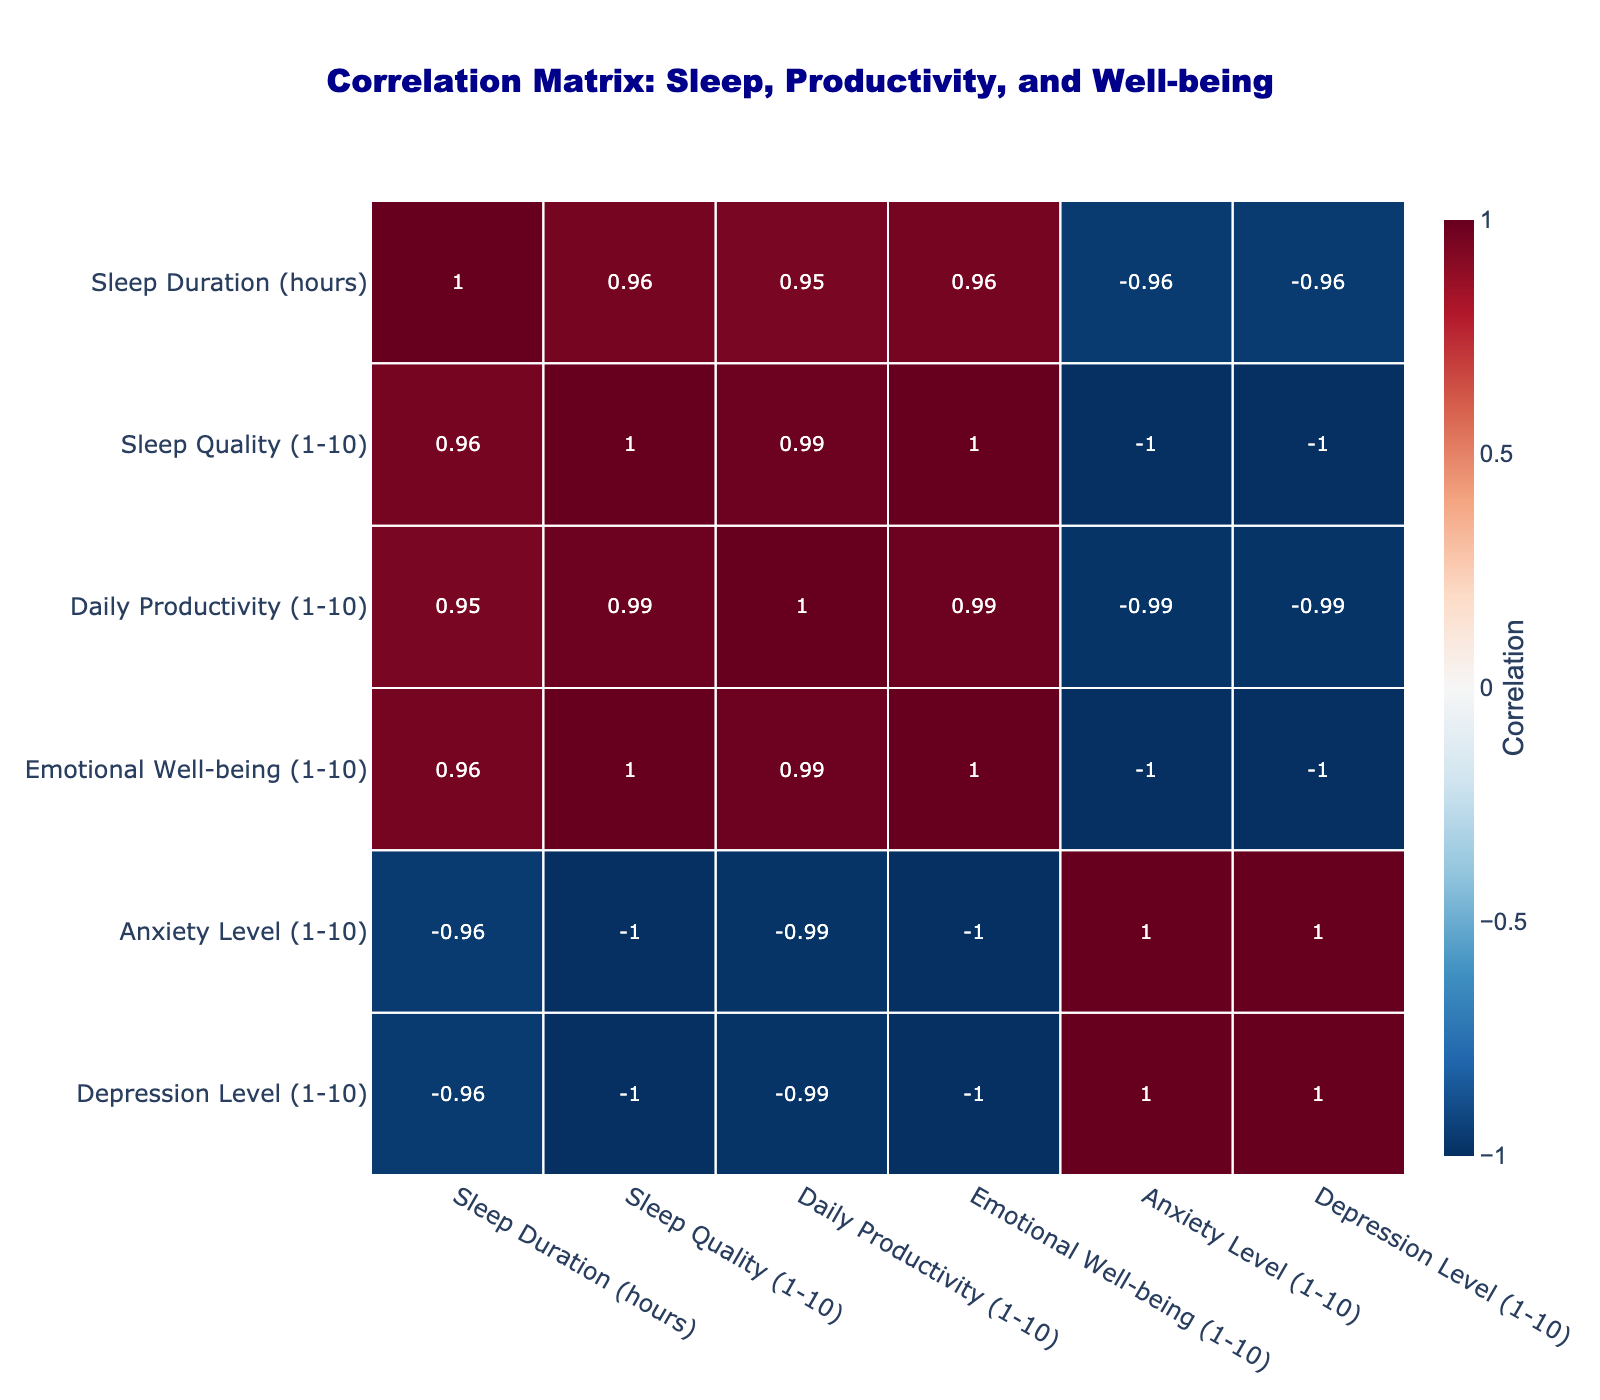What is the correlation between Sleep Quality and Daily Productivity? To find the correlation, we look at the corresponding values in the correlation matrix between Sleep Quality and Daily Productivity. The value is 0.83, indicating a strong positive correlation.
Answer: 0.83 What is the highest rated Emotional Well-being score in the table? By scanning the Emotional Well-being column, the highest value is 9, which corresponds to a sleep duration of 10 hours.
Answer: 9 Is there a negative correlation between Anxiety Level and Sleep Duration? The correlation matrix shows the value between Anxiety Level and Sleep Duration is -0.8, indicating a strong negative correlation. This suggests that as sleep duration increases, anxiety levels tend to decrease.
Answer: Yes What is the average Sleep Quality score for all individuals who slept for 6 hours? Looking at the Sleep Quality scores for individuals who slept for 6 hours (5, 4, 5), we calculate the average: (5 + 4 + 5)/3 = 4.67.
Answer: 4.67 Are higher Sleep Durations associated with lower Depression Levels? We can observe the correlation between Sleep Duration and Depression Level in the table. The correlation value is -0.86, indicating a strong negative correlation. This means that typically, longer sleep durations are linked with lower depression levels.
Answer: Yes What is the difference in Daily Productivity between the highest and lowest Sleep Quality scores? The highest Sleep Quality score is 9 with a corresponding Daily Productivity of 9, and the lowest Sleep Quality score is 3 with a Daily Productivity of 4. The difference is 9 - 4 = 5.
Answer: 5 What is the median Anxiety Level for the group that had 8 hours of sleep? The Anxiety Levels corresponding to 8 hours of sleep are 4, 4, and 3. To find the median, we sort these values (3, 4, 4) and identify the middle value, which is 4.
Answer: 4 How does increasing Sleep Duration affect Emotional Well-being based on the correlation matrix? The correlation between Sleep Duration and Emotional Well-being is 0.86, indicating a strong positive correlation. This suggests that as sleep duration increases, Emotional Well-being is likely to improve.
Answer: Increases Emotional Well-being What is the average Daily Productivity for individuals with an Anxiety Level of 8? The Anxiety Level of 8 corresponds to scores of Daily Productivity of 4 and 4. The average is (4 + 4)/2 = 4.
Answer: 4 Is there any case where Sleep Duration of 5 hours relates to better Emotional Well-being than a 6-hour sleep? For 5 hours of sleep, Emotional Well-being is rated at 4, while for 6 hours, it is rated at 5. Since 4 is less than 5, there are no cases where 5 hours results in better Emotional Well-being than 6 hours.
Answer: No 